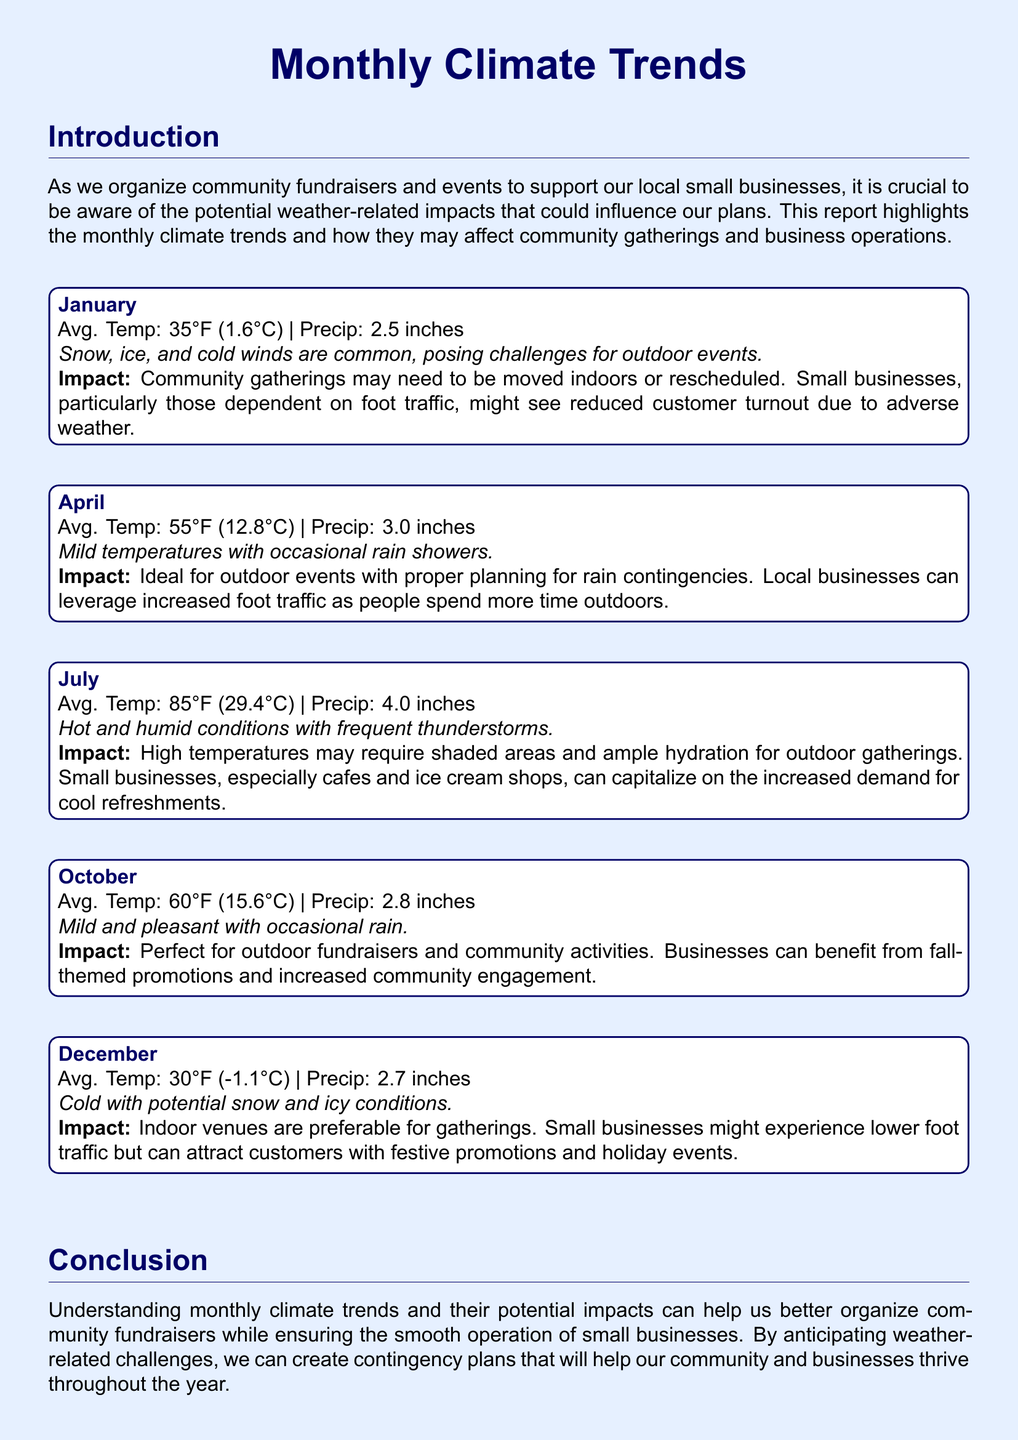What is the average temperature in July? The average temperature for July in the document is explicitly mentioned as 85°F (29.4°C).
Answer: 85°F (29.4°C) How much precipitation is expected in April? The document states that the expected precipitation in April is 3.0 inches.
Answer: 3.0 inches What weather condition is common in December? According to the report, December is characterized by cold with potential snow and icy conditions.
Answer: Cold with potential snow and icy conditions What is the recommended venue type for gatherings in January? The report suggests that community gatherings in January may need to be moved indoors or rescheduled due to adverse weather conditions.
Answer: Indoors What is the impact of July weather on local businesses? The report explains that hot temperatures in July may increase demand for cool refreshments at small businesses like cafes and ice cream shops.
Answer: Increased demand for cool refreshments Which month is considered ideal for outdoor events? The document mentions that April is ideal for outdoor events if proper planning for rain contingencies is made.
Answer: April How does October weather affect community engagement? According to the document, the mild and pleasant weather in October is perfect for outdoor fundraisers and community activities, leading to increased engagement.
Answer: Increased community engagement What type of promotions can businesses use in December? The report states that small businesses might attract customers with festive promotions and holiday events in December.
Answer: Festive promotions and holiday events What is the general impact of January weather on small businesses? The document indicates that small businesses, particularly those dependent on foot traffic, might see reduced customer turnout in January due to adverse weather.
Answer: Reduced customer turnout 